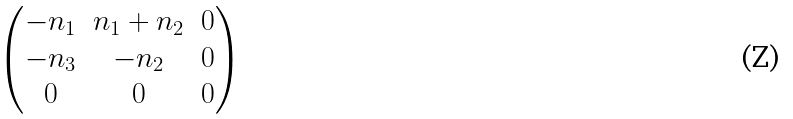<formula> <loc_0><loc_0><loc_500><loc_500>\left ( \begin{matrix} - n _ { 1 } & n _ { 1 } + n _ { 2 } & 0 \\ - n _ { 3 } & - n _ { 2 } & 0 \\ 0 & 0 & 0 \end{matrix} \right )</formula> 